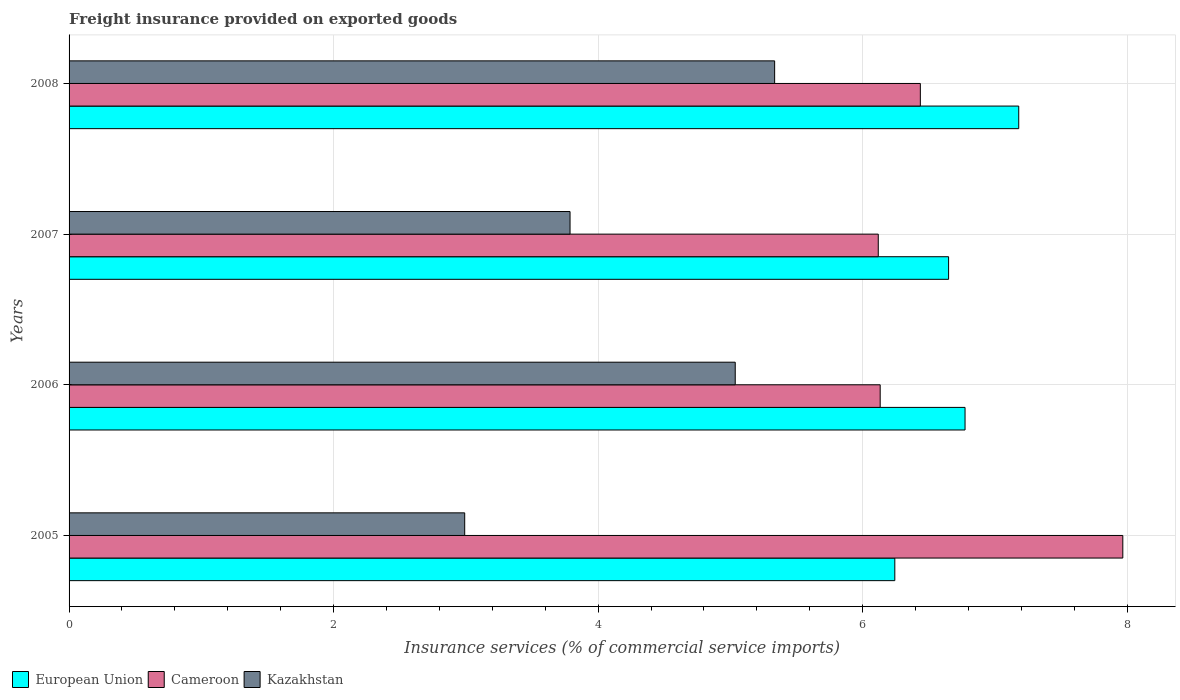Are the number of bars per tick equal to the number of legend labels?
Your answer should be compact. Yes. How many bars are there on the 2nd tick from the top?
Provide a succinct answer. 3. How many bars are there on the 2nd tick from the bottom?
Provide a succinct answer. 3. In how many cases, is the number of bars for a given year not equal to the number of legend labels?
Make the answer very short. 0. What is the freight insurance provided on exported goods in European Union in 2005?
Provide a short and direct response. 6.24. Across all years, what is the maximum freight insurance provided on exported goods in Cameroon?
Make the answer very short. 7.97. Across all years, what is the minimum freight insurance provided on exported goods in Cameroon?
Offer a terse response. 6.12. In which year was the freight insurance provided on exported goods in Cameroon minimum?
Your response must be concise. 2007. What is the total freight insurance provided on exported goods in European Union in the graph?
Give a very brief answer. 26.85. What is the difference between the freight insurance provided on exported goods in Cameroon in 2006 and that in 2008?
Your response must be concise. -0.3. What is the difference between the freight insurance provided on exported goods in European Union in 2008 and the freight insurance provided on exported goods in Kazakhstan in 2007?
Offer a terse response. 3.39. What is the average freight insurance provided on exported goods in European Union per year?
Provide a short and direct response. 6.71. In the year 2008, what is the difference between the freight insurance provided on exported goods in Kazakhstan and freight insurance provided on exported goods in European Union?
Provide a succinct answer. -1.85. What is the ratio of the freight insurance provided on exported goods in European Union in 2005 to that in 2006?
Make the answer very short. 0.92. Is the difference between the freight insurance provided on exported goods in Kazakhstan in 2006 and 2008 greater than the difference between the freight insurance provided on exported goods in European Union in 2006 and 2008?
Your answer should be very brief. Yes. What is the difference between the highest and the second highest freight insurance provided on exported goods in European Union?
Offer a very short reply. 0.41. What is the difference between the highest and the lowest freight insurance provided on exported goods in Cameroon?
Your answer should be compact. 1.85. What does the 3rd bar from the bottom in 2005 represents?
Give a very brief answer. Kazakhstan. Is it the case that in every year, the sum of the freight insurance provided on exported goods in European Union and freight insurance provided on exported goods in Cameroon is greater than the freight insurance provided on exported goods in Kazakhstan?
Offer a terse response. Yes. How many bars are there?
Your response must be concise. 12. What is the difference between two consecutive major ticks on the X-axis?
Provide a succinct answer. 2. Does the graph contain any zero values?
Your answer should be compact. No. Does the graph contain grids?
Offer a very short reply. Yes. Where does the legend appear in the graph?
Ensure brevity in your answer.  Bottom left. What is the title of the graph?
Provide a short and direct response. Freight insurance provided on exported goods. Does "Micronesia" appear as one of the legend labels in the graph?
Offer a terse response. No. What is the label or title of the X-axis?
Offer a terse response. Insurance services (% of commercial service imports). What is the Insurance services (% of commercial service imports) of European Union in 2005?
Offer a very short reply. 6.24. What is the Insurance services (% of commercial service imports) of Cameroon in 2005?
Your answer should be very brief. 7.97. What is the Insurance services (% of commercial service imports) in Kazakhstan in 2005?
Provide a succinct answer. 2.99. What is the Insurance services (% of commercial service imports) in European Union in 2006?
Offer a terse response. 6.77. What is the Insurance services (% of commercial service imports) in Cameroon in 2006?
Make the answer very short. 6.13. What is the Insurance services (% of commercial service imports) of Kazakhstan in 2006?
Ensure brevity in your answer.  5.04. What is the Insurance services (% of commercial service imports) of European Union in 2007?
Offer a very short reply. 6.65. What is the Insurance services (% of commercial service imports) of Cameroon in 2007?
Ensure brevity in your answer.  6.12. What is the Insurance services (% of commercial service imports) of Kazakhstan in 2007?
Offer a very short reply. 3.79. What is the Insurance services (% of commercial service imports) in European Union in 2008?
Give a very brief answer. 7.18. What is the Insurance services (% of commercial service imports) in Cameroon in 2008?
Give a very brief answer. 6.44. What is the Insurance services (% of commercial service imports) of Kazakhstan in 2008?
Provide a succinct answer. 5.33. Across all years, what is the maximum Insurance services (% of commercial service imports) of European Union?
Provide a short and direct response. 7.18. Across all years, what is the maximum Insurance services (% of commercial service imports) of Cameroon?
Offer a very short reply. 7.97. Across all years, what is the maximum Insurance services (% of commercial service imports) in Kazakhstan?
Give a very brief answer. 5.33. Across all years, what is the minimum Insurance services (% of commercial service imports) of European Union?
Make the answer very short. 6.24. Across all years, what is the minimum Insurance services (% of commercial service imports) in Cameroon?
Your answer should be compact. 6.12. Across all years, what is the minimum Insurance services (% of commercial service imports) in Kazakhstan?
Give a very brief answer. 2.99. What is the total Insurance services (% of commercial service imports) in European Union in the graph?
Keep it short and to the point. 26.85. What is the total Insurance services (% of commercial service imports) of Cameroon in the graph?
Your answer should be very brief. 26.66. What is the total Insurance services (% of commercial service imports) of Kazakhstan in the graph?
Ensure brevity in your answer.  17.15. What is the difference between the Insurance services (% of commercial service imports) of European Union in 2005 and that in 2006?
Provide a succinct answer. -0.53. What is the difference between the Insurance services (% of commercial service imports) in Cameroon in 2005 and that in 2006?
Offer a very short reply. 1.83. What is the difference between the Insurance services (% of commercial service imports) in Kazakhstan in 2005 and that in 2006?
Provide a short and direct response. -2.05. What is the difference between the Insurance services (% of commercial service imports) of European Union in 2005 and that in 2007?
Ensure brevity in your answer.  -0.41. What is the difference between the Insurance services (% of commercial service imports) of Cameroon in 2005 and that in 2007?
Give a very brief answer. 1.85. What is the difference between the Insurance services (% of commercial service imports) of Kazakhstan in 2005 and that in 2007?
Offer a very short reply. -0.8. What is the difference between the Insurance services (% of commercial service imports) in European Union in 2005 and that in 2008?
Your response must be concise. -0.94. What is the difference between the Insurance services (% of commercial service imports) in Cameroon in 2005 and that in 2008?
Your answer should be compact. 1.53. What is the difference between the Insurance services (% of commercial service imports) in Kazakhstan in 2005 and that in 2008?
Provide a succinct answer. -2.34. What is the difference between the Insurance services (% of commercial service imports) of European Union in 2006 and that in 2007?
Your response must be concise. 0.12. What is the difference between the Insurance services (% of commercial service imports) in Cameroon in 2006 and that in 2007?
Provide a succinct answer. 0.01. What is the difference between the Insurance services (% of commercial service imports) of Kazakhstan in 2006 and that in 2007?
Offer a terse response. 1.25. What is the difference between the Insurance services (% of commercial service imports) in European Union in 2006 and that in 2008?
Give a very brief answer. -0.41. What is the difference between the Insurance services (% of commercial service imports) in Cameroon in 2006 and that in 2008?
Provide a short and direct response. -0.3. What is the difference between the Insurance services (% of commercial service imports) of Kazakhstan in 2006 and that in 2008?
Provide a succinct answer. -0.3. What is the difference between the Insurance services (% of commercial service imports) of European Union in 2007 and that in 2008?
Offer a terse response. -0.53. What is the difference between the Insurance services (% of commercial service imports) of Cameroon in 2007 and that in 2008?
Your answer should be very brief. -0.32. What is the difference between the Insurance services (% of commercial service imports) in Kazakhstan in 2007 and that in 2008?
Keep it short and to the point. -1.55. What is the difference between the Insurance services (% of commercial service imports) of European Union in 2005 and the Insurance services (% of commercial service imports) of Cameroon in 2006?
Your response must be concise. 0.11. What is the difference between the Insurance services (% of commercial service imports) in European Union in 2005 and the Insurance services (% of commercial service imports) in Kazakhstan in 2006?
Offer a terse response. 1.21. What is the difference between the Insurance services (% of commercial service imports) in Cameroon in 2005 and the Insurance services (% of commercial service imports) in Kazakhstan in 2006?
Offer a terse response. 2.93. What is the difference between the Insurance services (% of commercial service imports) in European Union in 2005 and the Insurance services (% of commercial service imports) in Cameroon in 2007?
Your answer should be very brief. 0.13. What is the difference between the Insurance services (% of commercial service imports) in European Union in 2005 and the Insurance services (% of commercial service imports) in Kazakhstan in 2007?
Offer a terse response. 2.46. What is the difference between the Insurance services (% of commercial service imports) in Cameroon in 2005 and the Insurance services (% of commercial service imports) in Kazakhstan in 2007?
Your answer should be very brief. 4.18. What is the difference between the Insurance services (% of commercial service imports) in European Union in 2005 and the Insurance services (% of commercial service imports) in Cameroon in 2008?
Offer a terse response. -0.19. What is the difference between the Insurance services (% of commercial service imports) in European Union in 2005 and the Insurance services (% of commercial service imports) in Kazakhstan in 2008?
Give a very brief answer. 0.91. What is the difference between the Insurance services (% of commercial service imports) of Cameroon in 2005 and the Insurance services (% of commercial service imports) of Kazakhstan in 2008?
Ensure brevity in your answer.  2.63. What is the difference between the Insurance services (% of commercial service imports) in European Union in 2006 and the Insurance services (% of commercial service imports) in Cameroon in 2007?
Your answer should be compact. 0.66. What is the difference between the Insurance services (% of commercial service imports) of European Union in 2006 and the Insurance services (% of commercial service imports) of Kazakhstan in 2007?
Your answer should be very brief. 2.99. What is the difference between the Insurance services (% of commercial service imports) of Cameroon in 2006 and the Insurance services (% of commercial service imports) of Kazakhstan in 2007?
Provide a succinct answer. 2.35. What is the difference between the Insurance services (% of commercial service imports) in European Union in 2006 and the Insurance services (% of commercial service imports) in Cameroon in 2008?
Offer a terse response. 0.34. What is the difference between the Insurance services (% of commercial service imports) of European Union in 2006 and the Insurance services (% of commercial service imports) of Kazakhstan in 2008?
Your response must be concise. 1.44. What is the difference between the Insurance services (% of commercial service imports) in Cameroon in 2006 and the Insurance services (% of commercial service imports) in Kazakhstan in 2008?
Your answer should be very brief. 0.8. What is the difference between the Insurance services (% of commercial service imports) in European Union in 2007 and the Insurance services (% of commercial service imports) in Cameroon in 2008?
Ensure brevity in your answer.  0.21. What is the difference between the Insurance services (% of commercial service imports) of European Union in 2007 and the Insurance services (% of commercial service imports) of Kazakhstan in 2008?
Your answer should be compact. 1.32. What is the difference between the Insurance services (% of commercial service imports) of Cameroon in 2007 and the Insurance services (% of commercial service imports) of Kazakhstan in 2008?
Offer a very short reply. 0.78. What is the average Insurance services (% of commercial service imports) of European Union per year?
Offer a terse response. 6.71. What is the average Insurance services (% of commercial service imports) in Cameroon per year?
Offer a terse response. 6.66. What is the average Insurance services (% of commercial service imports) of Kazakhstan per year?
Make the answer very short. 4.29. In the year 2005, what is the difference between the Insurance services (% of commercial service imports) of European Union and Insurance services (% of commercial service imports) of Cameroon?
Your response must be concise. -1.72. In the year 2005, what is the difference between the Insurance services (% of commercial service imports) of European Union and Insurance services (% of commercial service imports) of Kazakhstan?
Offer a very short reply. 3.25. In the year 2005, what is the difference between the Insurance services (% of commercial service imports) in Cameroon and Insurance services (% of commercial service imports) in Kazakhstan?
Your answer should be very brief. 4.98. In the year 2006, what is the difference between the Insurance services (% of commercial service imports) of European Union and Insurance services (% of commercial service imports) of Cameroon?
Give a very brief answer. 0.64. In the year 2006, what is the difference between the Insurance services (% of commercial service imports) of European Union and Insurance services (% of commercial service imports) of Kazakhstan?
Keep it short and to the point. 1.74. In the year 2006, what is the difference between the Insurance services (% of commercial service imports) in Cameroon and Insurance services (% of commercial service imports) in Kazakhstan?
Your response must be concise. 1.1. In the year 2007, what is the difference between the Insurance services (% of commercial service imports) of European Union and Insurance services (% of commercial service imports) of Cameroon?
Ensure brevity in your answer.  0.53. In the year 2007, what is the difference between the Insurance services (% of commercial service imports) in European Union and Insurance services (% of commercial service imports) in Kazakhstan?
Keep it short and to the point. 2.86. In the year 2007, what is the difference between the Insurance services (% of commercial service imports) of Cameroon and Insurance services (% of commercial service imports) of Kazakhstan?
Offer a very short reply. 2.33. In the year 2008, what is the difference between the Insurance services (% of commercial service imports) of European Union and Insurance services (% of commercial service imports) of Cameroon?
Provide a short and direct response. 0.74. In the year 2008, what is the difference between the Insurance services (% of commercial service imports) in European Union and Insurance services (% of commercial service imports) in Kazakhstan?
Offer a terse response. 1.85. In the year 2008, what is the difference between the Insurance services (% of commercial service imports) of Cameroon and Insurance services (% of commercial service imports) of Kazakhstan?
Provide a succinct answer. 1.1. What is the ratio of the Insurance services (% of commercial service imports) in European Union in 2005 to that in 2006?
Your response must be concise. 0.92. What is the ratio of the Insurance services (% of commercial service imports) in Cameroon in 2005 to that in 2006?
Ensure brevity in your answer.  1.3. What is the ratio of the Insurance services (% of commercial service imports) of Kazakhstan in 2005 to that in 2006?
Your answer should be very brief. 0.59. What is the ratio of the Insurance services (% of commercial service imports) of European Union in 2005 to that in 2007?
Ensure brevity in your answer.  0.94. What is the ratio of the Insurance services (% of commercial service imports) in Cameroon in 2005 to that in 2007?
Keep it short and to the point. 1.3. What is the ratio of the Insurance services (% of commercial service imports) in Kazakhstan in 2005 to that in 2007?
Make the answer very short. 0.79. What is the ratio of the Insurance services (% of commercial service imports) in European Union in 2005 to that in 2008?
Offer a very short reply. 0.87. What is the ratio of the Insurance services (% of commercial service imports) of Cameroon in 2005 to that in 2008?
Provide a succinct answer. 1.24. What is the ratio of the Insurance services (% of commercial service imports) in Kazakhstan in 2005 to that in 2008?
Offer a terse response. 0.56. What is the ratio of the Insurance services (% of commercial service imports) in European Union in 2006 to that in 2007?
Ensure brevity in your answer.  1.02. What is the ratio of the Insurance services (% of commercial service imports) in Kazakhstan in 2006 to that in 2007?
Keep it short and to the point. 1.33. What is the ratio of the Insurance services (% of commercial service imports) of European Union in 2006 to that in 2008?
Keep it short and to the point. 0.94. What is the ratio of the Insurance services (% of commercial service imports) in Cameroon in 2006 to that in 2008?
Give a very brief answer. 0.95. What is the ratio of the Insurance services (% of commercial service imports) of Kazakhstan in 2006 to that in 2008?
Ensure brevity in your answer.  0.94. What is the ratio of the Insurance services (% of commercial service imports) in European Union in 2007 to that in 2008?
Offer a terse response. 0.93. What is the ratio of the Insurance services (% of commercial service imports) of Cameroon in 2007 to that in 2008?
Ensure brevity in your answer.  0.95. What is the ratio of the Insurance services (% of commercial service imports) of Kazakhstan in 2007 to that in 2008?
Offer a very short reply. 0.71. What is the difference between the highest and the second highest Insurance services (% of commercial service imports) of European Union?
Offer a terse response. 0.41. What is the difference between the highest and the second highest Insurance services (% of commercial service imports) of Cameroon?
Give a very brief answer. 1.53. What is the difference between the highest and the second highest Insurance services (% of commercial service imports) of Kazakhstan?
Your response must be concise. 0.3. What is the difference between the highest and the lowest Insurance services (% of commercial service imports) of European Union?
Your answer should be compact. 0.94. What is the difference between the highest and the lowest Insurance services (% of commercial service imports) in Cameroon?
Make the answer very short. 1.85. What is the difference between the highest and the lowest Insurance services (% of commercial service imports) in Kazakhstan?
Your answer should be very brief. 2.34. 